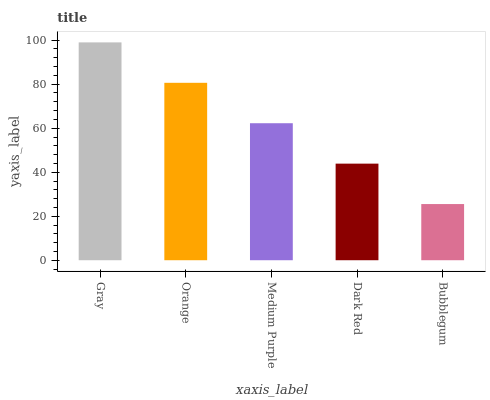Is Bubblegum the minimum?
Answer yes or no. Yes. Is Gray the maximum?
Answer yes or no. Yes. Is Orange the minimum?
Answer yes or no. No. Is Orange the maximum?
Answer yes or no. No. Is Gray greater than Orange?
Answer yes or no. Yes. Is Orange less than Gray?
Answer yes or no. Yes. Is Orange greater than Gray?
Answer yes or no. No. Is Gray less than Orange?
Answer yes or no. No. Is Medium Purple the high median?
Answer yes or no. Yes. Is Medium Purple the low median?
Answer yes or no. Yes. Is Bubblegum the high median?
Answer yes or no. No. Is Orange the low median?
Answer yes or no. No. 